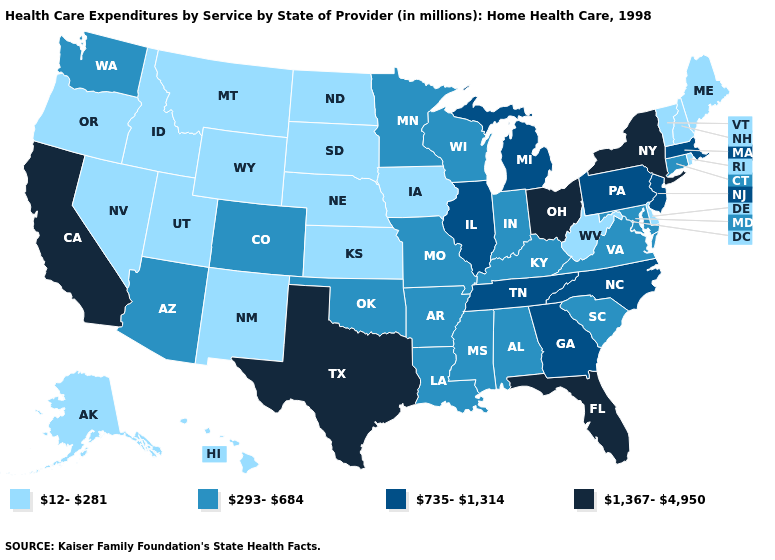How many symbols are there in the legend?
Short answer required. 4. What is the value of Louisiana?
Answer briefly. 293-684. Is the legend a continuous bar?
Write a very short answer. No. Does the map have missing data?
Give a very brief answer. No. Among the states that border Michigan , which have the lowest value?
Be succinct. Indiana, Wisconsin. Among the states that border North Carolina , does Tennessee have the highest value?
Write a very short answer. Yes. What is the highest value in the MidWest ?
Short answer required. 1,367-4,950. What is the value of Arizona?
Give a very brief answer. 293-684. Among the states that border Missouri , which have the lowest value?
Be succinct. Iowa, Kansas, Nebraska. Does Ohio have the highest value in the USA?
Quick response, please. Yes. What is the value of Florida?
Answer briefly. 1,367-4,950. Name the states that have a value in the range 293-684?
Give a very brief answer. Alabama, Arizona, Arkansas, Colorado, Connecticut, Indiana, Kentucky, Louisiana, Maryland, Minnesota, Mississippi, Missouri, Oklahoma, South Carolina, Virginia, Washington, Wisconsin. Does Kansas have a lower value than Wisconsin?
Concise answer only. Yes. Does the map have missing data?
Short answer required. No. Which states have the lowest value in the USA?
Answer briefly. Alaska, Delaware, Hawaii, Idaho, Iowa, Kansas, Maine, Montana, Nebraska, Nevada, New Hampshire, New Mexico, North Dakota, Oregon, Rhode Island, South Dakota, Utah, Vermont, West Virginia, Wyoming. 